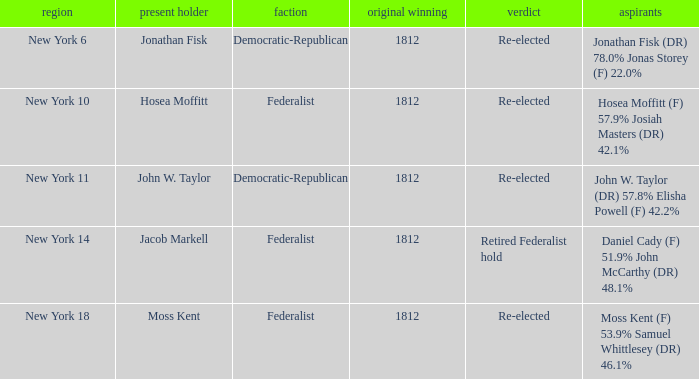Name the incumbent for new york 10 Hosea Moffitt. 